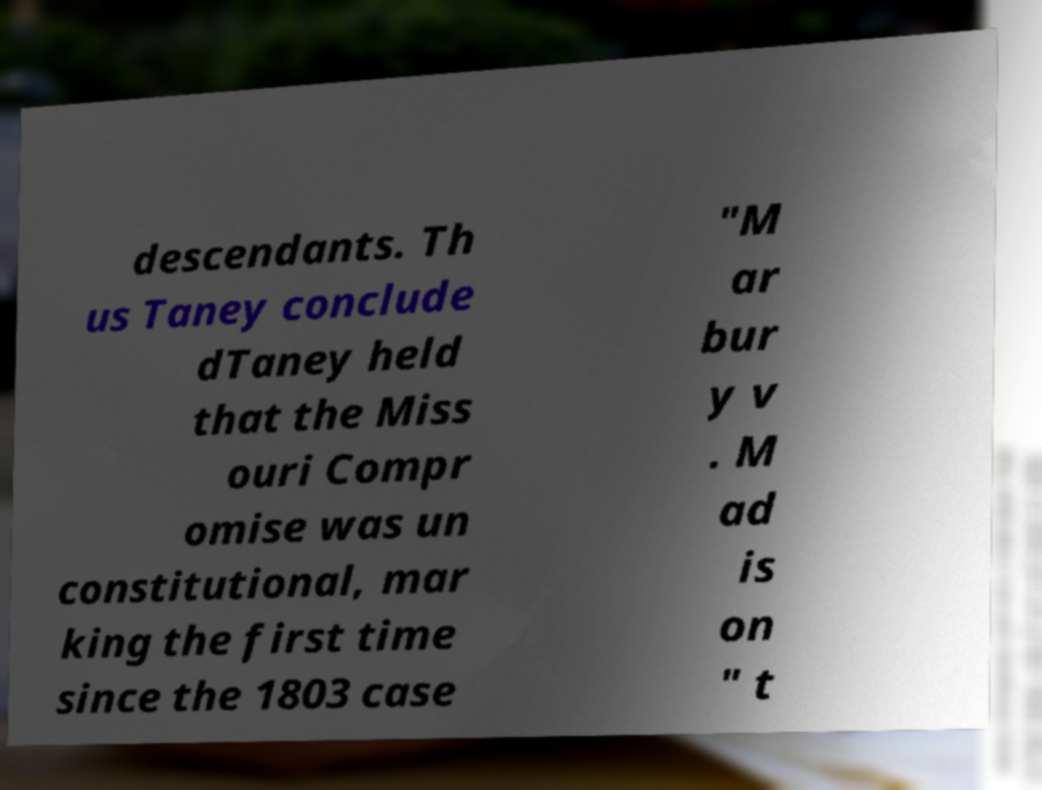Could you extract and type out the text from this image? descendants. Th us Taney conclude dTaney held that the Miss ouri Compr omise was un constitutional, mar king the first time since the 1803 case "M ar bur y v . M ad is on " t 